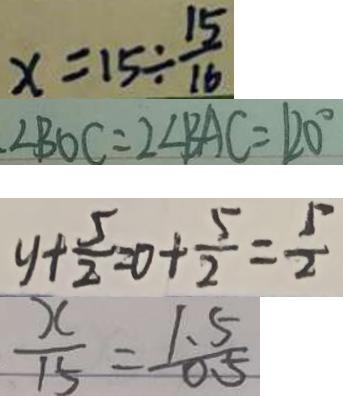Convert formula to latex. <formula><loc_0><loc_0><loc_500><loc_500>x = 1 5 \div \frac { 1 5 } { 1 6 } 
 \angle B O C = 2 \angle B A C = 1 2 0 ^ { \circ } 
 y + \frac { 5 } { 2 } = 0 + \frac { 5 } { 2 } = \frac { 5 } { 2 } 
 \frac { x } { 1 5 } = \frac { 1 . 5 } { 0 . 5 }</formula> 